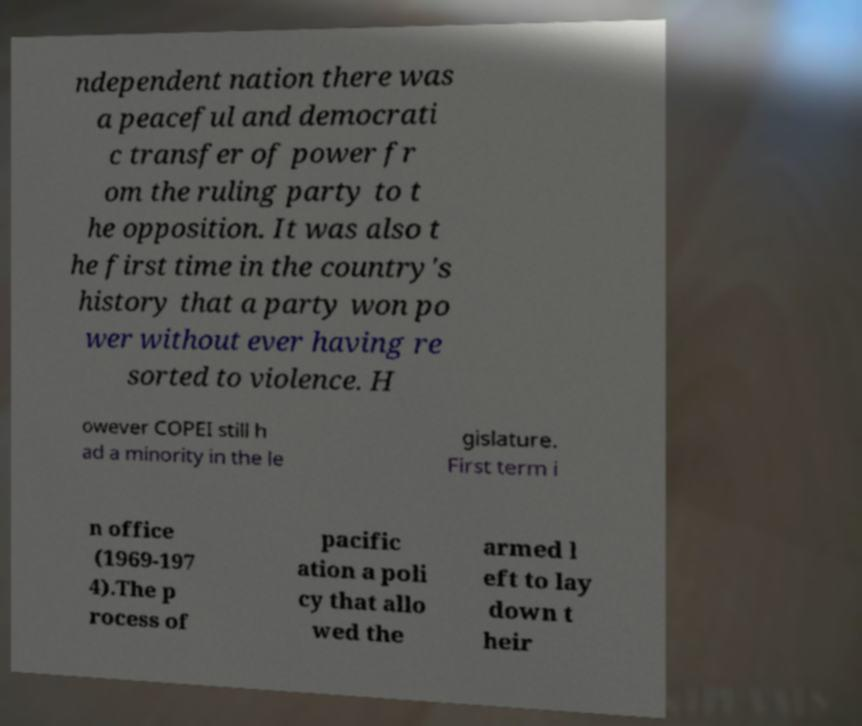For documentation purposes, I need the text within this image transcribed. Could you provide that? ndependent nation there was a peaceful and democrati c transfer of power fr om the ruling party to t he opposition. It was also t he first time in the country's history that a party won po wer without ever having re sorted to violence. H owever COPEI still h ad a minority in the le gislature. First term i n office (1969-197 4).The p rocess of pacific ation a poli cy that allo wed the armed l eft to lay down t heir 